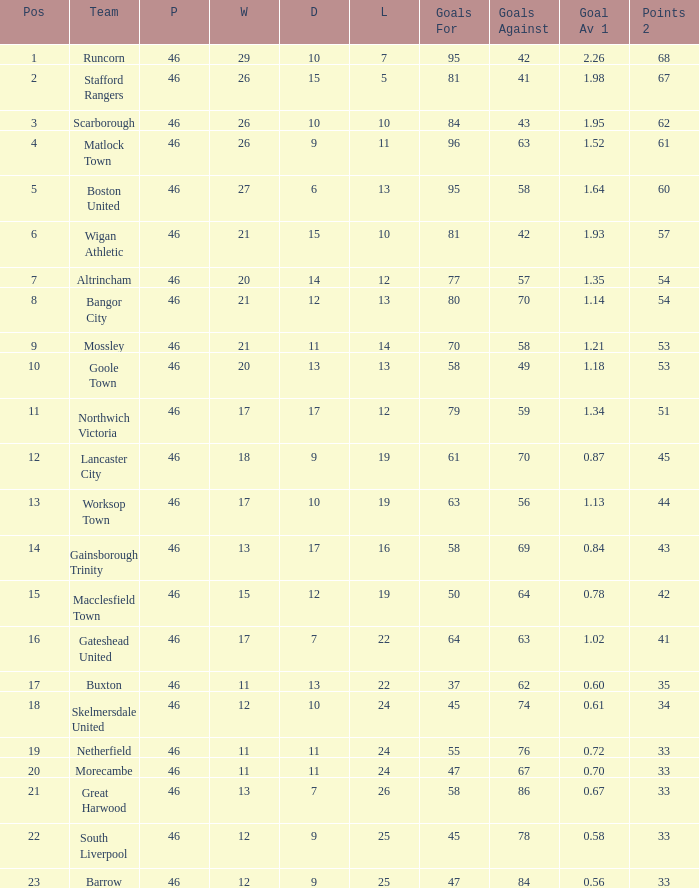Which team had goal averages of 1.34? Northwich Victoria. 